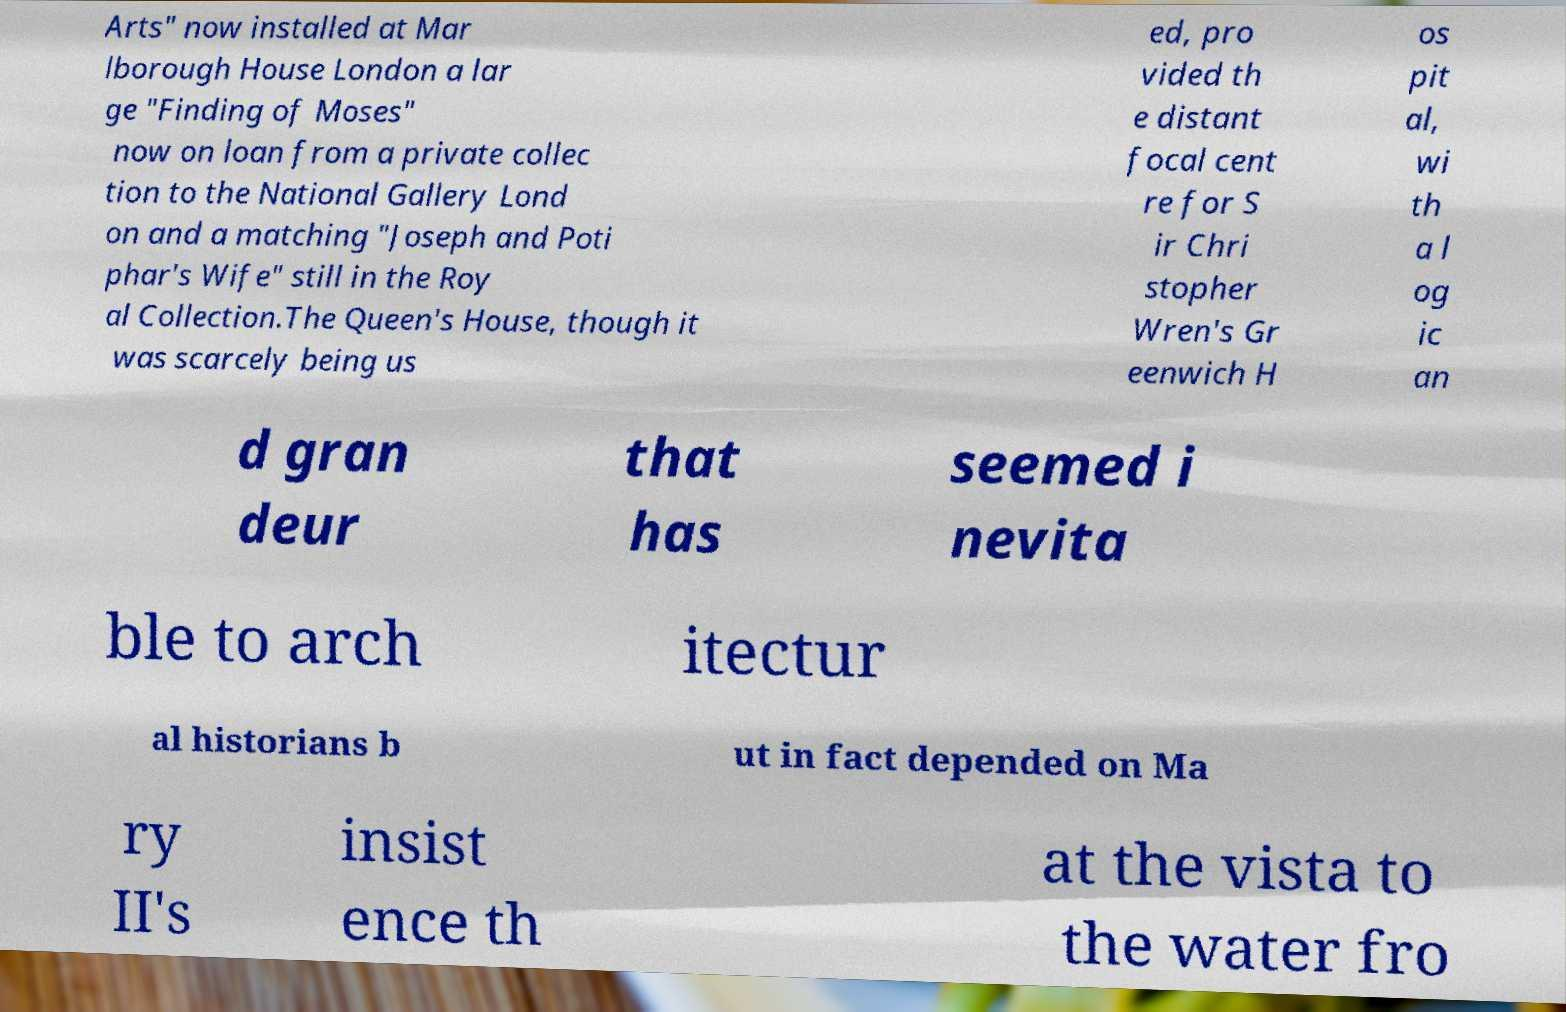I need the written content from this picture converted into text. Can you do that? Arts" now installed at Mar lborough House London a lar ge "Finding of Moses" now on loan from a private collec tion to the National Gallery Lond on and a matching "Joseph and Poti phar's Wife" still in the Roy al Collection.The Queen's House, though it was scarcely being us ed, pro vided th e distant focal cent re for S ir Chri stopher Wren's Gr eenwich H os pit al, wi th a l og ic an d gran deur that has seemed i nevita ble to arch itectur al historians b ut in fact depended on Ma ry II's insist ence th at the vista to the water fro 